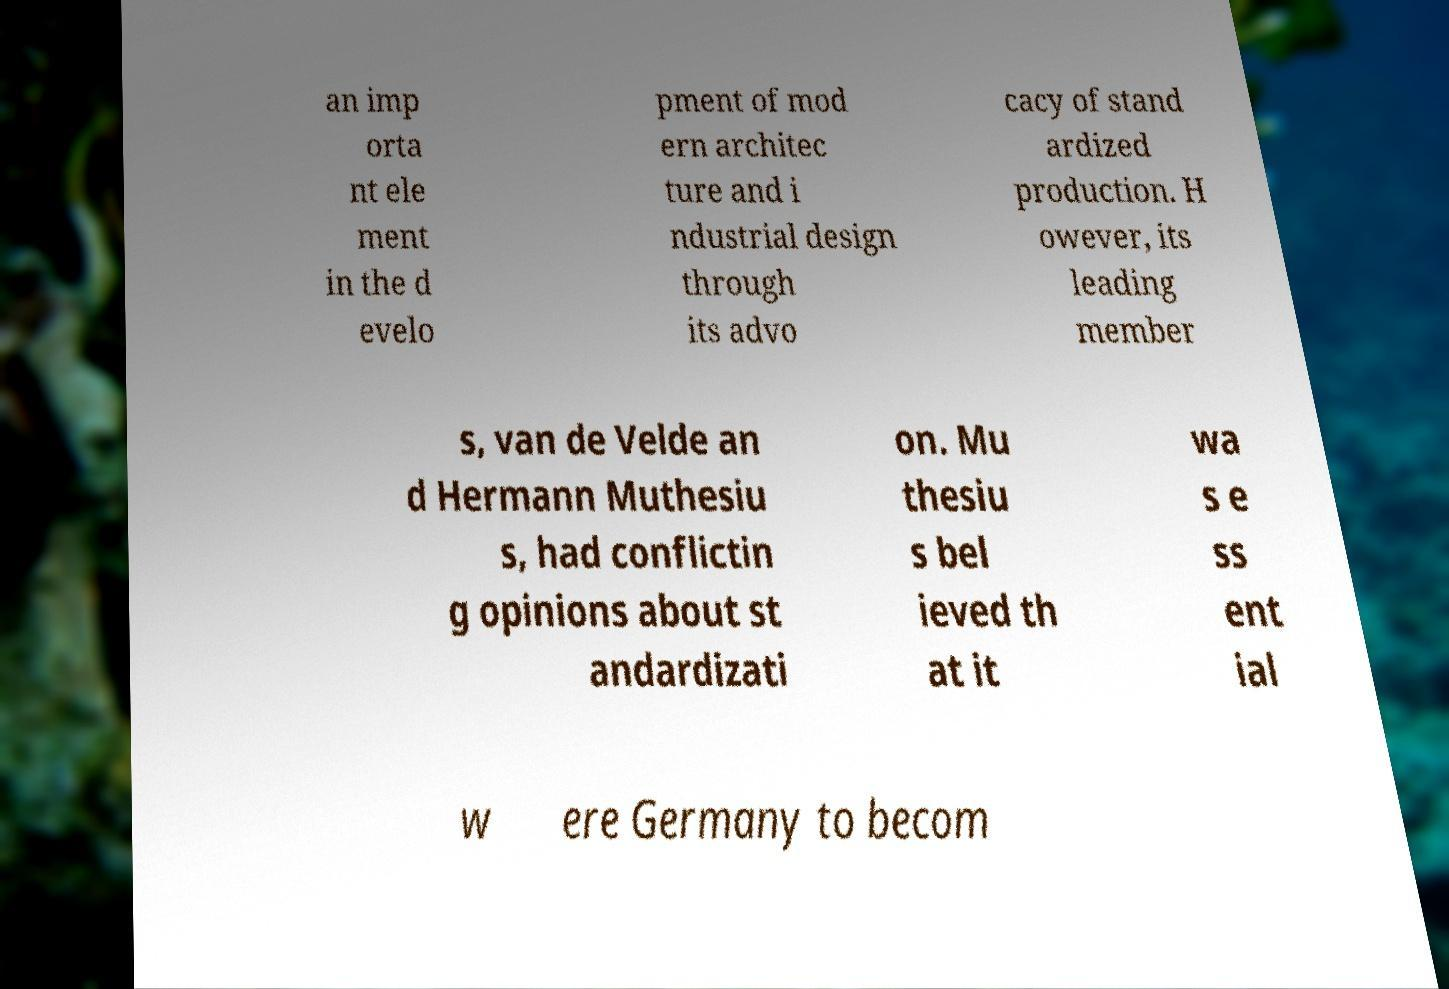For documentation purposes, I need the text within this image transcribed. Could you provide that? an imp orta nt ele ment in the d evelo pment of mod ern architec ture and i ndustrial design through its advo cacy of stand ardized production. H owever, its leading member s, van de Velde an d Hermann Muthesiu s, had conflictin g opinions about st andardizati on. Mu thesiu s bel ieved th at it wa s e ss ent ial w ere Germany to becom 